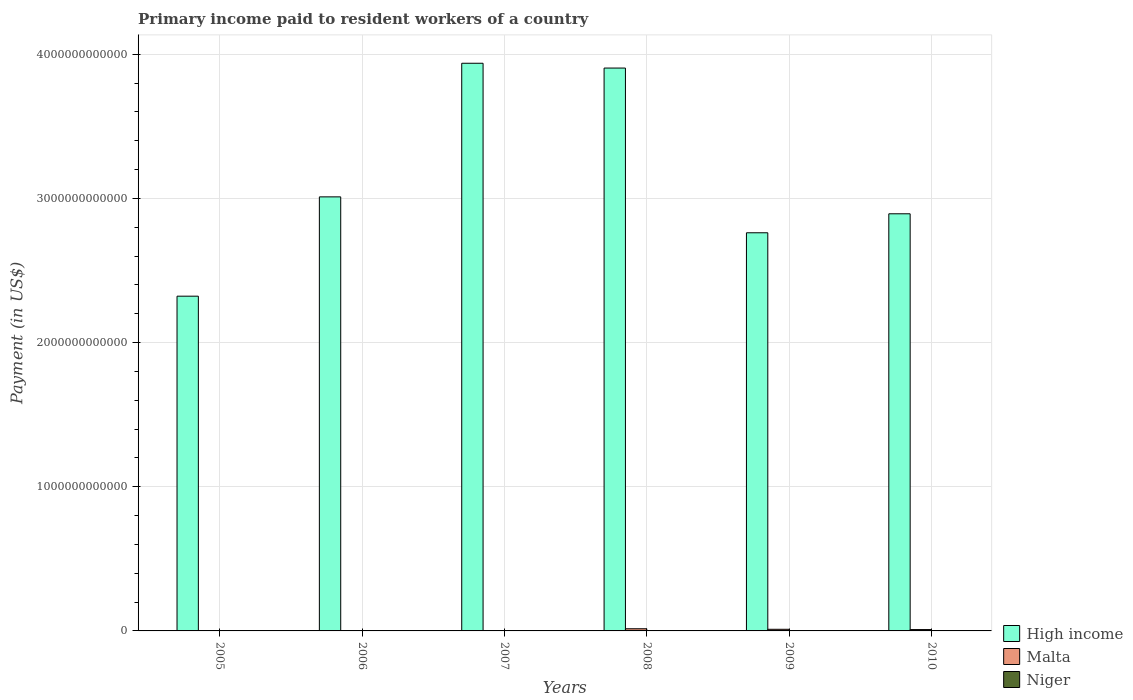How many different coloured bars are there?
Ensure brevity in your answer.  3. How many groups of bars are there?
Give a very brief answer. 6. Are the number of bars per tick equal to the number of legend labels?
Provide a succinct answer. Yes. What is the label of the 1st group of bars from the left?
Give a very brief answer. 2005. In how many cases, is the number of bars for a given year not equal to the number of legend labels?
Give a very brief answer. 0. What is the amount paid to workers in High income in 2006?
Ensure brevity in your answer.  3.01e+12. Across all years, what is the maximum amount paid to workers in Malta?
Provide a short and direct response. 1.50e+1. Across all years, what is the minimum amount paid to workers in Niger?
Provide a succinct answer. 4.08e+07. In which year was the amount paid to workers in High income maximum?
Keep it short and to the point. 2007. What is the total amount paid to workers in Niger in the graph?
Offer a very short reply. 4.39e+08. What is the difference between the amount paid to workers in Niger in 2008 and that in 2009?
Offer a very short reply. -7.21e+07. What is the difference between the amount paid to workers in High income in 2010 and the amount paid to workers in Niger in 2009?
Make the answer very short. 2.89e+12. What is the average amount paid to workers in Niger per year?
Your answer should be compact. 7.32e+07. In the year 2005, what is the difference between the amount paid to workers in Niger and amount paid to workers in High income?
Your answer should be compact. -2.32e+12. What is the ratio of the amount paid to workers in Niger in 2008 to that in 2010?
Provide a succinct answer. 0.51. Is the difference between the amount paid to workers in Niger in 2005 and 2007 greater than the difference between the amount paid to workers in High income in 2005 and 2007?
Give a very brief answer. Yes. What is the difference between the highest and the second highest amount paid to workers in High income?
Provide a succinct answer. 3.33e+1. What is the difference between the highest and the lowest amount paid to workers in Niger?
Your answer should be very brief. 8.70e+07. In how many years, is the amount paid to workers in Malta greater than the average amount paid to workers in Malta taken over all years?
Give a very brief answer. 3. Is the sum of the amount paid to workers in Niger in 2007 and 2010 greater than the maximum amount paid to workers in High income across all years?
Provide a short and direct response. No. What does the 2nd bar from the left in 2008 represents?
Give a very brief answer. Malta. What does the 1st bar from the right in 2007 represents?
Offer a terse response. Niger. How many years are there in the graph?
Ensure brevity in your answer.  6. What is the difference between two consecutive major ticks on the Y-axis?
Offer a very short reply. 1.00e+12. Does the graph contain any zero values?
Your answer should be compact. No. How many legend labels are there?
Make the answer very short. 3. What is the title of the graph?
Keep it short and to the point. Primary income paid to resident workers of a country. Does "Zambia" appear as one of the legend labels in the graph?
Ensure brevity in your answer.  No. What is the label or title of the Y-axis?
Ensure brevity in your answer.  Payment (in US$). What is the Payment (in US$) in High income in 2005?
Make the answer very short. 2.32e+12. What is the Payment (in US$) in Malta in 2005?
Provide a short and direct response. 1.45e+09. What is the Payment (in US$) of Niger in 2005?
Make the answer very short. 4.66e+07. What is the Payment (in US$) of High income in 2006?
Your response must be concise. 3.01e+12. What is the Payment (in US$) of Malta in 2006?
Keep it short and to the point. 2.05e+09. What is the Payment (in US$) in Niger in 2006?
Make the answer very short. 4.08e+07. What is the Payment (in US$) in High income in 2007?
Offer a terse response. 3.94e+12. What is the Payment (in US$) of Malta in 2007?
Keep it short and to the point. 2.88e+09. What is the Payment (in US$) of Niger in 2007?
Ensure brevity in your answer.  5.96e+07. What is the Payment (in US$) of High income in 2008?
Your answer should be very brief. 3.90e+12. What is the Payment (in US$) of Malta in 2008?
Your response must be concise. 1.50e+1. What is the Payment (in US$) in Niger in 2008?
Your response must be concise. 5.56e+07. What is the Payment (in US$) in High income in 2009?
Ensure brevity in your answer.  2.76e+12. What is the Payment (in US$) in Malta in 2009?
Your answer should be compact. 1.13e+1. What is the Payment (in US$) in Niger in 2009?
Provide a short and direct response. 1.28e+08. What is the Payment (in US$) in High income in 2010?
Provide a short and direct response. 2.89e+12. What is the Payment (in US$) of Malta in 2010?
Provide a short and direct response. 9.35e+09. What is the Payment (in US$) of Niger in 2010?
Your response must be concise. 1.09e+08. Across all years, what is the maximum Payment (in US$) in High income?
Give a very brief answer. 3.94e+12. Across all years, what is the maximum Payment (in US$) in Malta?
Make the answer very short. 1.50e+1. Across all years, what is the maximum Payment (in US$) of Niger?
Provide a short and direct response. 1.28e+08. Across all years, what is the minimum Payment (in US$) of High income?
Your answer should be very brief. 2.32e+12. Across all years, what is the minimum Payment (in US$) of Malta?
Make the answer very short. 1.45e+09. Across all years, what is the minimum Payment (in US$) of Niger?
Make the answer very short. 4.08e+07. What is the total Payment (in US$) in High income in the graph?
Provide a succinct answer. 1.88e+13. What is the total Payment (in US$) of Malta in the graph?
Offer a terse response. 4.21e+1. What is the total Payment (in US$) in Niger in the graph?
Offer a very short reply. 4.39e+08. What is the difference between the Payment (in US$) in High income in 2005 and that in 2006?
Give a very brief answer. -6.89e+11. What is the difference between the Payment (in US$) of Malta in 2005 and that in 2006?
Your response must be concise. -5.99e+08. What is the difference between the Payment (in US$) in Niger in 2005 and that in 2006?
Your answer should be very brief. 5.79e+06. What is the difference between the Payment (in US$) in High income in 2005 and that in 2007?
Offer a very short reply. -1.62e+12. What is the difference between the Payment (in US$) of Malta in 2005 and that in 2007?
Your answer should be compact. -1.42e+09. What is the difference between the Payment (in US$) in Niger in 2005 and that in 2007?
Offer a very short reply. -1.31e+07. What is the difference between the Payment (in US$) in High income in 2005 and that in 2008?
Keep it short and to the point. -1.58e+12. What is the difference between the Payment (in US$) in Malta in 2005 and that in 2008?
Your answer should be very brief. -1.36e+1. What is the difference between the Payment (in US$) in Niger in 2005 and that in 2008?
Your answer should be compact. -9.05e+06. What is the difference between the Payment (in US$) of High income in 2005 and that in 2009?
Give a very brief answer. -4.40e+11. What is the difference between the Payment (in US$) of Malta in 2005 and that in 2009?
Your answer should be compact. -9.86e+09. What is the difference between the Payment (in US$) in Niger in 2005 and that in 2009?
Offer a very short reply. -8.12e+07. What is the difference between the Payment (in US$) of High income in 2005 and that in 2010?
Provide a succinct answer. -5.72e+11. What is the difference between the Payment (in US$) in Malta in 2005 and that in 2010?
Offer a very short reply. -7.90e+09. What is the difference between the Payment (in US$) in Niger in 2005 and that in 2010?
Provide a short and direct response. -6.23e+07. What is the difference between the Payment (in US$) of High income in 2006 and that in 2007?
Provide a succinct answer. -9.27e+11. What is the difference between the Payment (in US$) in Malta in 2006 and that in 2007?
Give a very brief answer. -8.25e+08. What is the difference between the Payment (in US$) of Niger in 2006 and that in 2007?
Provide a succinct answer. -1.89e+07. What is the difference between the Payment (in US$) in High income in 2006 and that in 2008?
Your answer should be compact. -8.94e+11. What is the difference between the Payment (in US$) in Malta in 2006 and that in 2008?
Give a very brief answer. -1.30e+1. What is the difference between the Payment (in US$) of Niger in 2006 and that in 2008?
Your answer should be compact. -1.48e+07. What is the difference between the Payment (in US$) in High income in 2006 and that in 2009?
Offer a terse response. 2.49e+11. What is the difference between the Payment (in US$) in Malta in 2006 and that in 2009?
Your answer should be compact. -9.26e+09. What is the difference between the Payment (in US$) in Niger in 2006 and that in 2009?
Provide a succinct answer. -8.70e+07. What is the difference between the Payment (in US$) of High income in 2006 and that in 2010?
Give a very brief answer. 1.17e+11. What is the difference between the Payment (in US$) in Malta in 2006 and that in 2010?
Provide a succinct answer. -7.30e+09. What is the difference between the Payment (in US$) of Niger in 2006 and that in 2010?
Provide a succinct answer. -6.81e+07. What is the difference between the Payment (in US$) in High income in 2007 and that in 2008?
Offer a very short reply. 3.33e+1. What is the difference between the Payment (in US$) in Malta in 2007 and that in 2008?
Your response must be concise. -1.21e+1. What is the difference between the Payment (in US$) in Niger in 2007 and that in 2008?
Make the answer very short. 4.01e+06. What is the difference between the Payment (in US$) of High income in 2007 and that in 2009?
Ensure brevity in your answer.  1.18e+12. What is the difference between the Payment (in US$) of Malta in 2007 and that in 2009?
Offer a terse response. -8.43e+09. What is the difference between the Payment (in US$) of Niger in 2007 and that in 2009?
Give a very brief answer. -6.81e+07. What is the difference between the Payment (in US$) of High income in 2007 and that in 2010?
Ensure brevity in your answer.  1.04e+12. What is the difference between the Payment (in US$) of Malta in 2007 and that in 2010?
Keep it short and to the point. -6.47e+09. What is the difference between the Payment (in US$) in Niger in 2007 and that in 2010?
Your response must be concise. -4.92e+07. What is the difference between the Payment (in US$) in High income in 2008 and that in 2009?
Your answer should be compact. 1.14e+12. What is the difference between the Payment (in US$) of Malta in 2008 and that in 2009?
Your response must be concise. 3.71e+09. What is the difference between the Payment (in US$) of Niger in 2008 and that in 2009?
Your answer should be compact. -7.21e+07. What is the difference between the Payment (in US$) in High income in 2008 and that in 2010?
Your answer should be very brief. 1.01e+12. What is the difference between the Payment (in US$) in Malta in 2008 and that in 2010?
Make the answer very short. 5.67e+09. What is the difference between the Payment (in US$) of Niger in 2008 and that in 2010?
Provide a succinct answer. -5.32e+07. What is the difference between the Payment (in US$) of High income in 2009 and that in 2010?
Give a very brief answer. -1.32e+11. What is the difference between the Payment (in US$) in Malta in 2009 and that in 2010?
Offer a terse response. 1.96e+09. What is the difference between the Payment (in US$) of Niger in 2009 and that in 2010?
Keep it short and to the point. 1.89e+07. What is the difference between the Payment (in US$) of High income in 2005 and the Payment (in US$) of Malta in 2006?
Your response must be concise. 2.32e+12. What is the difference between the Payment (in US$) of High income in 2005 and the Payment (in US$) of Niger in 2006?
Provide a short and direct response. 2.32e+12. What is the difference between the Payment (in US$) in Malta in 2005 and the Payment (in US$) in Niger in 2006?
Offer a very short reply. 1.41e+09. What is the difference between the Payment (in US$) in High income in 2005 and the Payment (in US$) in Malta in 2007?
Provide a succinct answer. 2.32e+12. What is the difference between the Payment (in US$) of High income in 2005 and the Payment (in US$) of Niger in 2007?
Give a very brief answer. 2.32e+12. What is the difference between the Payment (in US$) of Malta in 2005 and the Payment (in US$) of Niger in 2007?
Provide a short and direct response. 1.40e+09. What is the difference between the Payment (in US$) in High income in 2005 and the Payment (in US$) in Malta in 2008?
Your response must be concise. 2.31e+12. What is the difference between the Payment (in US$) in High income in 2005 and the Payment (in US$) in Niger in 2008?
Offer a very short reply. 2.32e+12. What is the difference between the Payment (in US$) of Malta in 2005 and the Payment (in US$) of Niger in 2008?
Keep it short and to the point. 1.40e+09. What is the difference between the Payment (in US$) of High income in 2005 and the Payment (in US$) of Malta in 2009?
Offer a very short reply. 2.31e+12. What is the difference between the Payment (in US$) of High income in 2005 and the Payment (in US$) of Niger in 2009?
Give a very brief answer. 2.32e+12. What is the difference between the Payment (in US$) in Malta in 2005 and the Payment (in US$) in Niger in 2009?
Make the answer very short. 1.33e+09. What is the difference between the Payment (in US$) of High income in 2005 and the Payment (in US$) of Malta in 2010?
Offer a very short reply. 2.31e+12. What is the difference between the Payment (in US$) of High income in 2005 and the Payment (in US$) of Niger in 2010?
Keep it short and to the point. 2.32e+12. What is the difference between the Payment (in US$) of Malta in 2005 and the Payment (in US$) of Niger in 2010?
Your answer should be compact. 1.35e+09. What is the difference between the Payment (in US$) of High income in 2006 and the Payment (in US$) of Malta in 2007?
Offer a very short reply. 3.01e+12. What is the difference between the Payment (in US$) in High income in 2006 and the Payment (in US$) in Niger in 2007?
Provide a short and direct response. 3.01e+12. What is the difference between the Payment (in US$) of Malta in 2006 and the Payment (in US$) of Niger in 2007?
Provide a short and direct response. 1.99e+09. What is the difference between the Payment (in US$) in High income in 2006 and the Payment (in US$) in Malta in 2008?
Your response must be concise. 3.00e+12. What is the difference between the Payment (in US$) of High income in 2006 and the Payment (in US$) of Niger in 2008?
Ensure brevity in your answer.  3.01e+12. What is the difference between the Payment (in US$) in Malta in 2006 and the Payment (in US$) in Niger in 2008?
Give a very brief answer. 2.00e+09. What is the difference between the Payment (in US$) in High income in 2006 and the Payment (in US$) in Malta in 2009?
Offer a very short reply. 3.00e+12. What is the difference between the Payment (in US$) in High income in 2006 and the Payment (in US$) in Niger in 2009?
Your answer should be very brief. 3.01e+12. What is the difference between the Payment (in US$) in Malta in 2006 and the Payment (in US$) in Niger in 2009?
Your answer should be compact. 1.93e+09. What is the difference between the Payment (in US$) in High income in 2006 and the Payment (in US$) in Malta in 2010?
Your answer should be compact. 3.00e+12. What is the difference between the Payment (in US$) of High income in 2006 and the Payment (in US$) of Niger in 2010?
Your answer should be compact. 3.01e+12. What is the difference between the Payment (in US$) of Malta in 2006 and the Payment (in US$) of Niger in 2010?
Your response must be concise. 1.94e+09. What is the difference between the Payment (in US$) of High income in 2007 and the Payment (in US$) of Malta in 2008?
Offer a terse response. 3.92e+12. What is the difference between the Payment (in US$) of High income in 2007 and the Payment (in US$) of Niger in 2008?
Keep it short and to the point. 3.94e+12. What is the difference between the Payment (in US$) in Malta in 2007 and the Payment (in US$) in Niger in 2008?
Provide a short and direct response. 2.82e+09. What is the difference between the Payment (in US$) in High income in 2007 and the Payment (in US$) in Malta in 2009?
Your response must be concise. 3.93e+12. What is the difference between the Payment (in US$) of High income in 2007 and the Payment (in US$) of Niger in 2009?
Your answer should be compact. 3.94e+12. What is the difference between the Payment (in US$) of Malta in 2007 and the Payment (in US$) of Niger in 2009?
Your answer should be compact. 2.75e+09. What is the difference between the Payment (in US$) of High income in 2007 and the Payment (in US$) of Malta in 2010?
Your answer should be compact. 3.93e+12. What is the difference between the Payment (in US$) in High income in 2007 and the Payment (in US$) in Niger in 2010?
Your answer should be compact. 3.94e+12. What is the difference between the Payment (in US$) of Malta in 2007 and the Payment (in US$) of Niger in 2010?
Make the answer very short. 2.77e+09. What is the difference between the Payment (in US$) of High income in 2008 and the Payment (in US$) of Malta in 2009?
Offer a very short reply. 3.89e+12. What is the difference between the Payment (in US$) of High income in 2008 and the Payment (in US$) of Niger in 2009?
Ensure brevity in your answer.  3.90e+12. What is the difference between the Payment (in US$) in Malta in 2008 and the Payment (in US$) in Niger in 2009?
Ensure brevity in your answer.  1.49e+1. What is the difference between the Payment (in US$) in High income in 2008 and the Payment (in US$) in Malta in 2010?
Ensure brevity in your answer.  3.90e+12. What is the difference between the Payment (in US$) of High income in 2008 and the Payment (in US$) of Niger in 2010?
Keep it short and to the point. 3.90e+12. What is the difference between the Payment (in US$) of Malta in 2008 and the Payment (in US$) of Niger in 2010?
Keep it short and to the point. 1.49e+1. What is the difference between the Payment (in US$) of High income in 2009 and the Payment (in US$) of Malta in 2010?
Keep it short and to the point. 2.75e+12. What is the difference between the Payment (in US$) of High income in 2009 and the Payment (in US$) of Niger in 2010?
Provide a short and direct response. 2.76e+12. What is the difference between the Payment (in US$) in Malta in 2009 and the Payment (in US$) in Niger in 2010?
Offer a terse response. 1.12e+1. What is the average Payment (in US$) in High income per year?
Your response must be concise. 3.14e+12. What is the average Payment (in US$) of Malta per year?
Ensure brevity in your answer.  7.01e+09. What is the average Payment (in US$) in Niger per year?
Offer a terse response. 7.32e+07. In the year 2005, what is the difference between the Payment (in US$) in High income and Payment (in US$) in Malta?
Provide a succinct answer. 2.32e+12. In the year 2005, what is the difference between the Payment (in US$) of High income and Payment (in US$) of Niger?
Your answer should be compact. 2.32e+12. In the year 2005, what is the difference between the Payment (in US$) of Malta and Payment (in US$) of Niger?
Ensure brevity in your answer.  1.41e+09. In the year 2006, what is the difference between the Payment (in US$) in High income and Payment (in US$) in Malta?
Give a very brief answer. 3.01e+12. In the year 2006, what is the difference between the Payment (in US$) of High income and Payment (in US$) of Niger?
Your answer should be compact. 3.01e+12. In the year 2006, what is the difference between the Payment (in US$) in Malta and Payment (in US$) in Niger?
Your answer should be compact. 2.01e+09. In the year 2007, what is the difference between the Payment (in US$) in High income and Payment (in US$) in Malta?
Offer a very short reply. 3.93e+12. In the year 2007, what is the difference between the Payment (in US$) in High income and Payment (in US$) in Niger?
Keep it short and to the point. 3.94e+12. In the year 2007, what is the difference between the Payment (in US$) of Malta and Payment (in US$) of Niger?
Ensure brevity in your answer.  2.82e+09. In the year 2008, what is the difference between the Payment (in US$) in High income and Payment (in US$) in Malta?
Make the answer very short. 3.89e+12. In the year 2008, what is the difference between the Payment (in US$) of High income and Payment (in US$) of Niger?
Keep it short and to the point. 3.90e+12. In the year 2008, what is the difference between the Payment (in US$) in Malta and Payment (in US$) in Niger?
Provide a succinct answer. 1.50e+1. In the year 2009, what is the difference between the Payment (in US$) in High income and Payment (in US$) in Malta?
Your answer should be compact. 2.75e+12. In the year 2009, what is the difference between the Payment (in US$) in High income and Payment (in US$) in Niger?
Make the answer very short. 2.76e+12. In the year 2009, what is the difference between the Payment (in US$) in Malta and Payment (in US$) in Niger?
Your answer should be compact. 1.12e+1. In the year 2010, what is the difference between the Payment (in US$) in High income and Payment (in US$) in Malta?
Offer a very short reply. 2.88e+12. In the year 2010, what is the difference between the Payment (in US$) in High income and Payment (in US$) in Niger?
Your answer should be very brief. 2.89e+12. In the year 2010, what is the difference between the Payment (in US$) in Malta and Payment (in US$) in Niger?
Provide a short and direct response. 9.24e+09. What is the ratio of the Payment (in US$) of High income in 2005 to that in 2006?
Your response must be concise. 0.77. What is the ratio of the Payment (in US$) in Malta in 2005 to that in 2006?
Offer a very short reply. 0.71. What is the ratio of the Payment (in US$) of Niger in 2005 to that in 2006?
Ensure brevity in your answer.  1.14. What is the ratio of the Payment (in US$) in High income in 2005 to that in 2007?
Offer a very short reply. 0.59. What is the ratio of the Payment (in US$) of Malta in 2005 to that in 2007?
Ensure brevity in your answer.  0.51. What is the ratio of the Payment (in US$) in Niger in 2005 to that in 2007?
Your answer should be compact. 0.78. What is the ratio of the Payment (in US$) in High income in 2005 to that in 2008?
Offer a terse response. 0.59. What is the ratio of the Payment (in US$) of Malta in 2005 to that in 2008?
Ensure brevity in your answer.  0.1. What is the ratio of the Payment (in US$) of Niger in 2005 to that in 2008?
Provide a short and direct response. 0.84. What is the ratio of the Payment (in US$) in High income in 2005 to that in 2009?
Your response must be concise. 0.84. What is the ratio of the Payment (in US$) in Malta in 2005 to that in 2009?
Offer a very short reply. 0.13. What is the ratio of the Payment (in US$) of Niger in 2005 to that in 2009?
Keep it short and to the point. 0.36. What is the ratio of the Payment (in US$) of High income in 2005 to that in 2010?
Ensure brevity in your answer.  0.8. What is the ratio of the Payment (in US$) of Malta in 2005 to that in 2010?
Your answer should be very brief. 0.16. What is the ratio of the Payment (in US$) in Niger in 2005 to that in 2010?
Ensure brevity in your answer.  0.43. What is the ratio of the Payment (in US$) of High income in 2006 to that in 2007?
Give a very brief answer. 0.76. What is the ratio of the Payment (in US$) of Malta in 2006 to that in 2007?
Your answer should be very brief. 0.71. What is the ratio of the Payment (in US$) of Niger in 2006 to that in 2007?
Ensure brevity in your answer.  0.68. What is the ratio of the Payment (in US$) in High income in 2006 to that in 2008?
Make the answer very short. 0.77. What is the ratio of the Payment (in US$) in Malta in 2006 to that in 2008?
Your answer should be compact. 0.14. What is the ratio of the Payment (in US$) in Niger in 2006 to that in 2008?
Keep it short and to the point. 0.73. What is the ratio of the Payment (in US$) of High income in 2006 to that in 2009?
Your answer should be very brief. 1.09. What is the ratio of the Payment (in US$) in Malta in 2006 to that in 2009?
Offer a terse response. 0.18. What is the ratio of the Payment (in US$) in Niger in 2006 to that in 2009?
Provide a short and direct response. 0.32. What is the ratio of the Payment (in US$) of High income in 2006 to that in 2010?
Keep it short and to the point. 1.04. What is the ratio of the Payment (in US$) in Malta in 2006 to that in 2010?
Your answer should be compact. 0.22. What is the ratio of the Payment (in US$) of Niger in 2006 to that in 2010?
Your answer should be compact. 0.37. What is the ratio of the Payment (in US$) of High income in 2007 to that in 2008?
Ensure brevity in your answer.  1.01. What is the ratio of the Payment (in US$) in Malta in 2007 to that in 2008?
Make the answer very short. 0.19. What is the ratio of the Payment (in US$) in Niger in 2007 to that in 2008?
Provide a succinct answer. 1.07. What is the ratio of the Payment (in US$) of High income in 2007 to that in 2009?
Keep it short and to the point. 1.43. What is the ratio of the Payment (in US$) in Malta in 2007 to that in 2009?
Your response must be concise. 0.25. What is the ratio of the Payment (in US$) of Niger in 2007 to that in 2009?
Your answer should be very brief. 0.47. What is the ratio of the Payment (in US$) of High income in 2007 to that in 2010?
Make the answer very short. 1.36. What is the ratio of the Payment (in US$) in Malta in 2007 to that in 2010?
Your answer should be compact. 0.31. What is the ratio of the Payment (in US$) of Niger in 2007 to that in 2010?
Your answer should be very brief. 0.55. What is the ratio of the Payment (in US$) in High income in 2008 to that in 2009?
Your response must be concise. 1.41. What is the ratio of the Payment (in US$) of Malta in 2008 to that in 2009?
Provide a succinct answer. 1.33. What is the ratio of the Payment (in US$) of Niger in 2008 to that in 2009?
Keep it short and to the point. 0.44. What is the ratio of the Payment (in US$) in High income in 2008 to that in 2010?
Offer a terse response. 1.35. What is the ratio of the Payment (in US$) of Malta in 2008 to that in 2010?
Keep it short and to the point. 1.61. What is the ratio of the Payment (in US$) of Niger in 2008 to that in 2010?
Your response must be concise. 0.51. What is the ratio of the Payment (in US$) of High income in 2009 to that in 2010?
Make the answer very short. 0.95. What is the ratio of the Payment (in US$) of Malta in 2009 to that in 2010?
Offer a very short reply. 1.21. What is the ratio of the Payment (in US$) of Niger in 2009 to that in 2010?
Ensure brevity in your answer.  1.17. What is the difference between the highest and the second highest Payment (in US$) in High income?
Keep it short and to the point. 3.33e+1. What is the difference between the highest and the second highest Payment (in US$) of Malta?
Offer a very short reply. 3.71e+09. What is the difference between the highest and the second highest Payment (in US$) of Niger?
Provide a short and direct response. 1.89e+07. What is the difference between the highest and the lowest Payment (in US$) in High income?
Your answer should be compact. 1.62e+12. What is the difference between the highest and the lowest Payment (in US$) in Malta?
Make the answer very short. 1.36e+1. What is the difference between the highest and the lowest Payment (in US$) of Niger?
Offer a very short reply. 8.70e+07. 